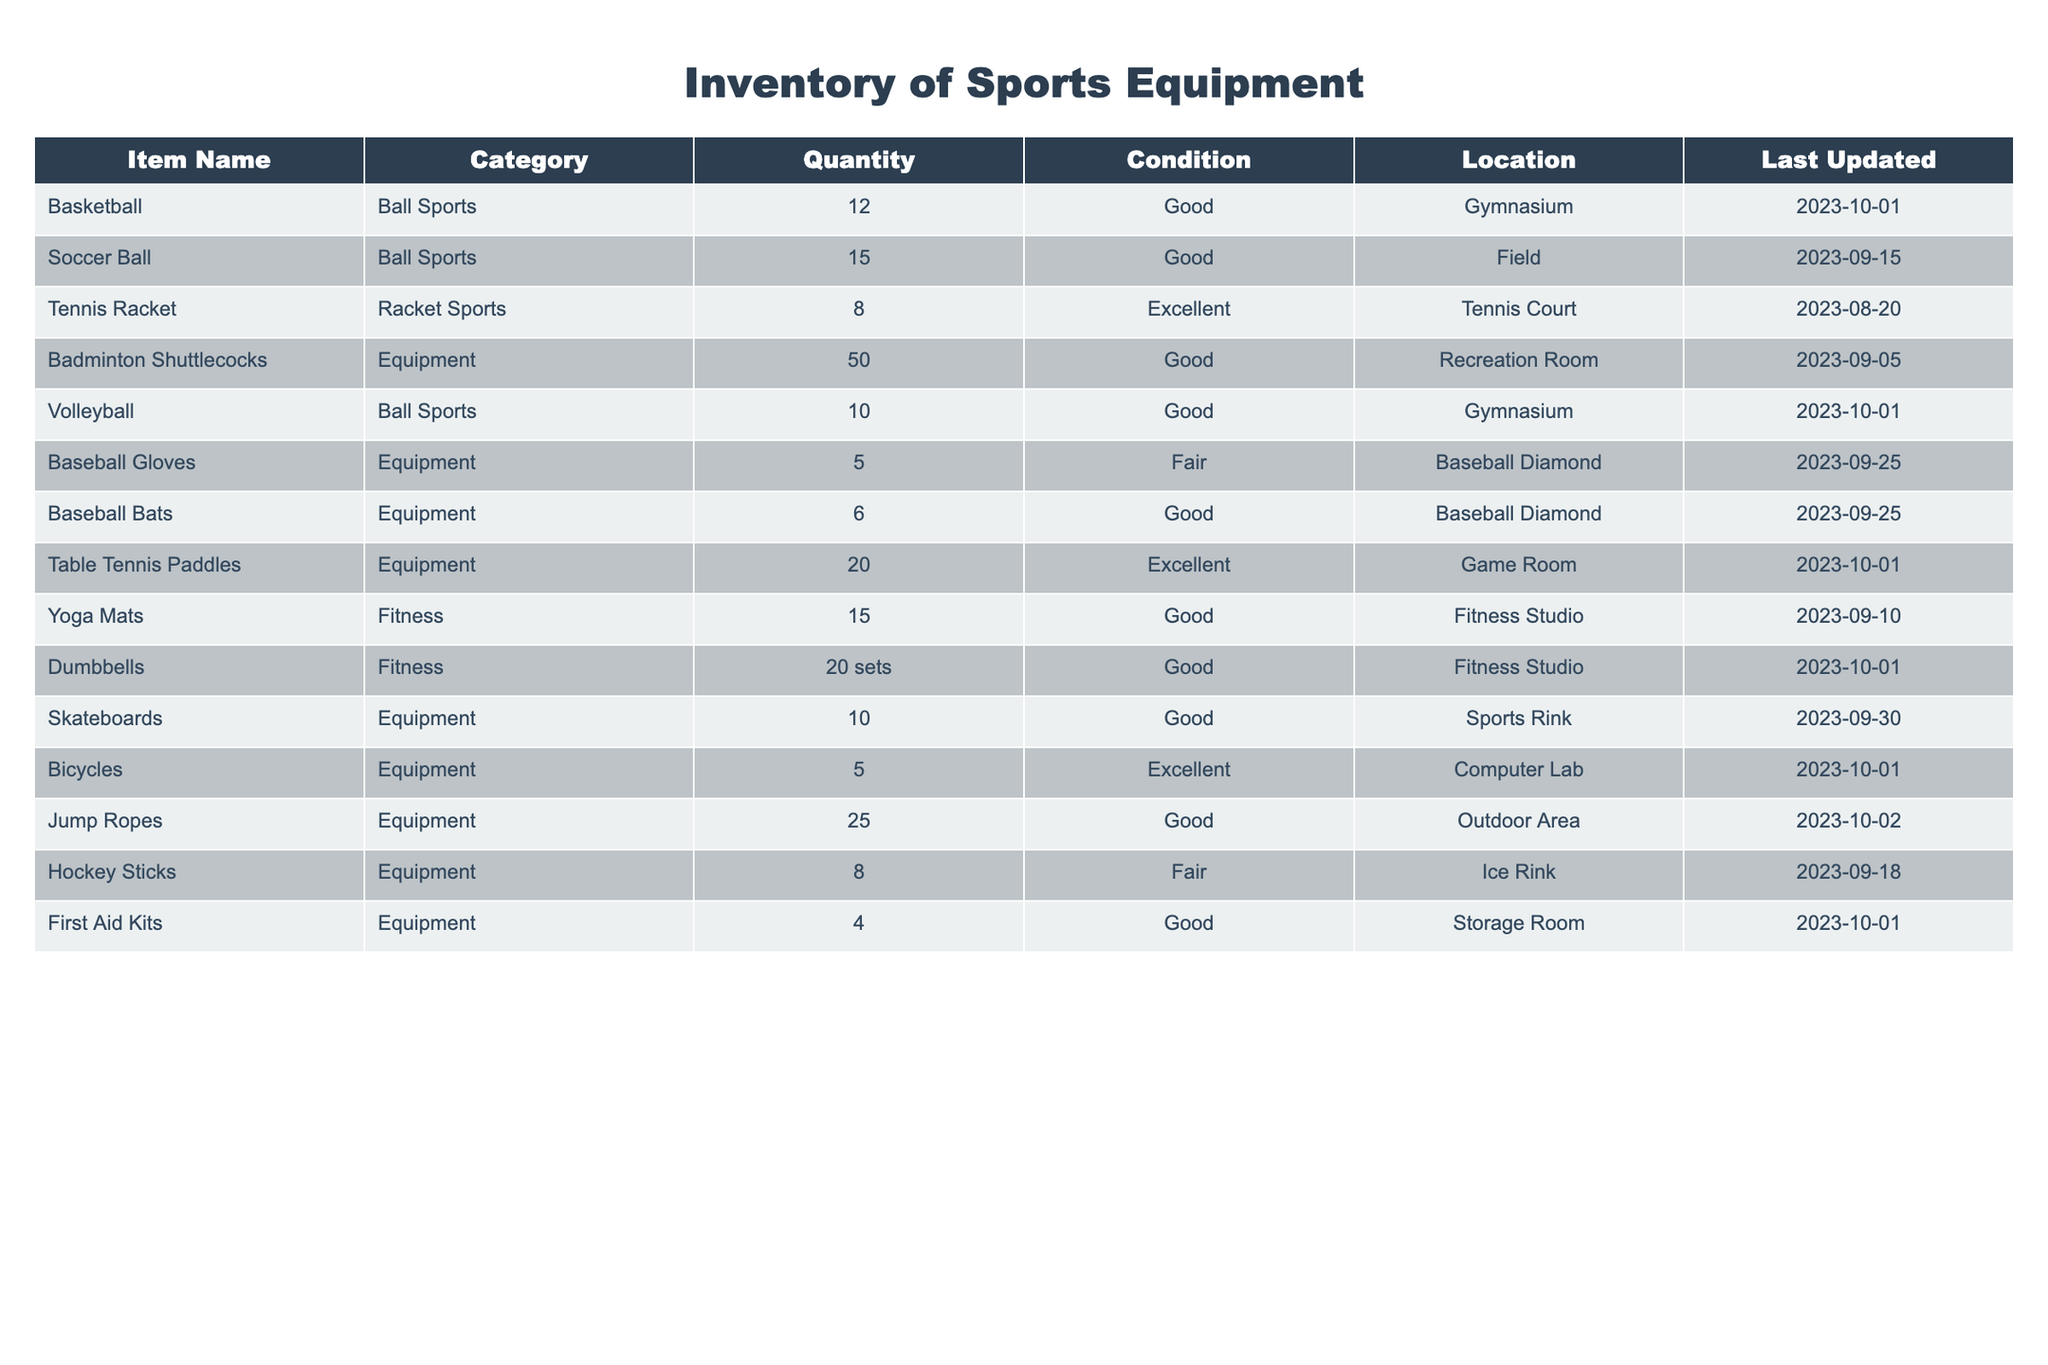What is the total quantity of basketballs available? The table lists the quantity of basketballs under the "Quantity" column for "Basketball". It states that there are 12 basketballs. Thus, the total quantity is directly taken from that entry.
Answer: 12 How many soccer balls are in good condition? The table indicates that there are 15 soccer balls listed under the "Quantity" column and they are categorized as "Good" in the "Condition" column. This shows that all 15 are in good condition.
Answer: 15 Are there more yoga mats than baseball bats? The table shows that there are 15 yoga mats and 6 baseball bats. Since 15 is greater than 6, the answer is yes.
Answer: Yes What equipment has the least quantity but is categorized as “Fair”? The "Condition" column has a category of "Fair" for two pieces of equipment: "Baseball Gloves" with a quantity of 5 and "Hockey Sticks" with a quantity of 8. Comparing these two, "Baseball Gloves" has the lesser quantity of 5.
Answer: Baseball Gloves What is the total quantity of equipment available in the Fitness category? The table shows two items in the Fitness category: "Yoga Mats" with 15 and "Dumbbells" listed as 20 sets. Summing these gives a total of 15 + 20 = 35.
Answer: 35 Which item has the highest quantity in the Ball Sports category? In the Ball Sports category, "Soccer Ball" has the highest quantity of 15, compared to 12 basketballs and 10 volleyballs listed. Therefore, "Soccer Ball" is the item with the highest quantity.
Answer: Soccer Ball Is there any equipment located in the storage room, and if so, what is it? The table lists "First Aid Kits" under the Equipment category with a quantity of 4 located in the "Storage Room". Therefore, yes, there is equipment there and it is First Aid Kits.
Answer: First Aid Kits What is the average quantity of sports equipment in the “Excellent” condition? Looking at the table, items in "Excellent" condition are "Tennis Racket" (8), "Table Tennis Paddles" (20), and "Bicycles" (5). The sum is 8 + 20 + 5 = 33, and there are 3 items, so the average is 33/3 = 11.
Answer: 11 Which location has the most pieces of equipment available? The locations and quantities are: Gymnasium (22), Field (15), Tennis Court (8), Recreation Room (50), Baseball Diamond (11), Game Room (20), Fitness Studio (35), Sports Rink (10), and Computer Lab (5). The Recreation Room has 50, making it the location with the most equipment.
Answer: Recreation Room 